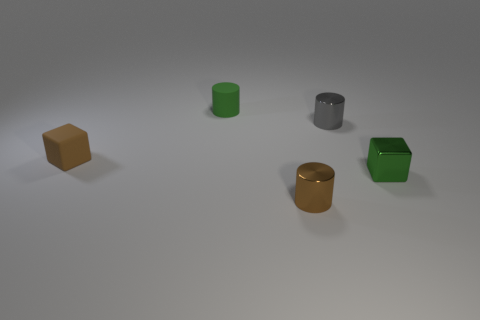There is another object that is the same shape as the tiny green shiny thing; what material is it?
Give a very brief answer. Rubber. What is the material of the green block that is the same size as the gray cylinder?
Offer a very short reply. Metal. What number of objects are either tiny brown things that are left of the small green matte object or green objects?
Provide a succinct answer. 3. Are there any green matte cylinders?
Offer a very short reply. Yes. There is a green thing that is left of the brown cylinder; what material is it?
Provide a succinct answer. Rubber. There is a cube that is the same color as the matte cylinder; what material is it?
Keep it short and to the point. Metal. How many large objects are either yellow rubber spheres or brown rubber things?
Make the answer very short. 0. What is the color of the tiny rubber block?
Give a very brief answer. Brown. Are there any rubber cylinders that are in front of the green object that is on the right side of the tiny green cylinder?
Offer a terse response. No. Is the number of rubber cubes behind the matte cube less than the number of green rubber cylinders?
Provide a succinct answer. Yes. 